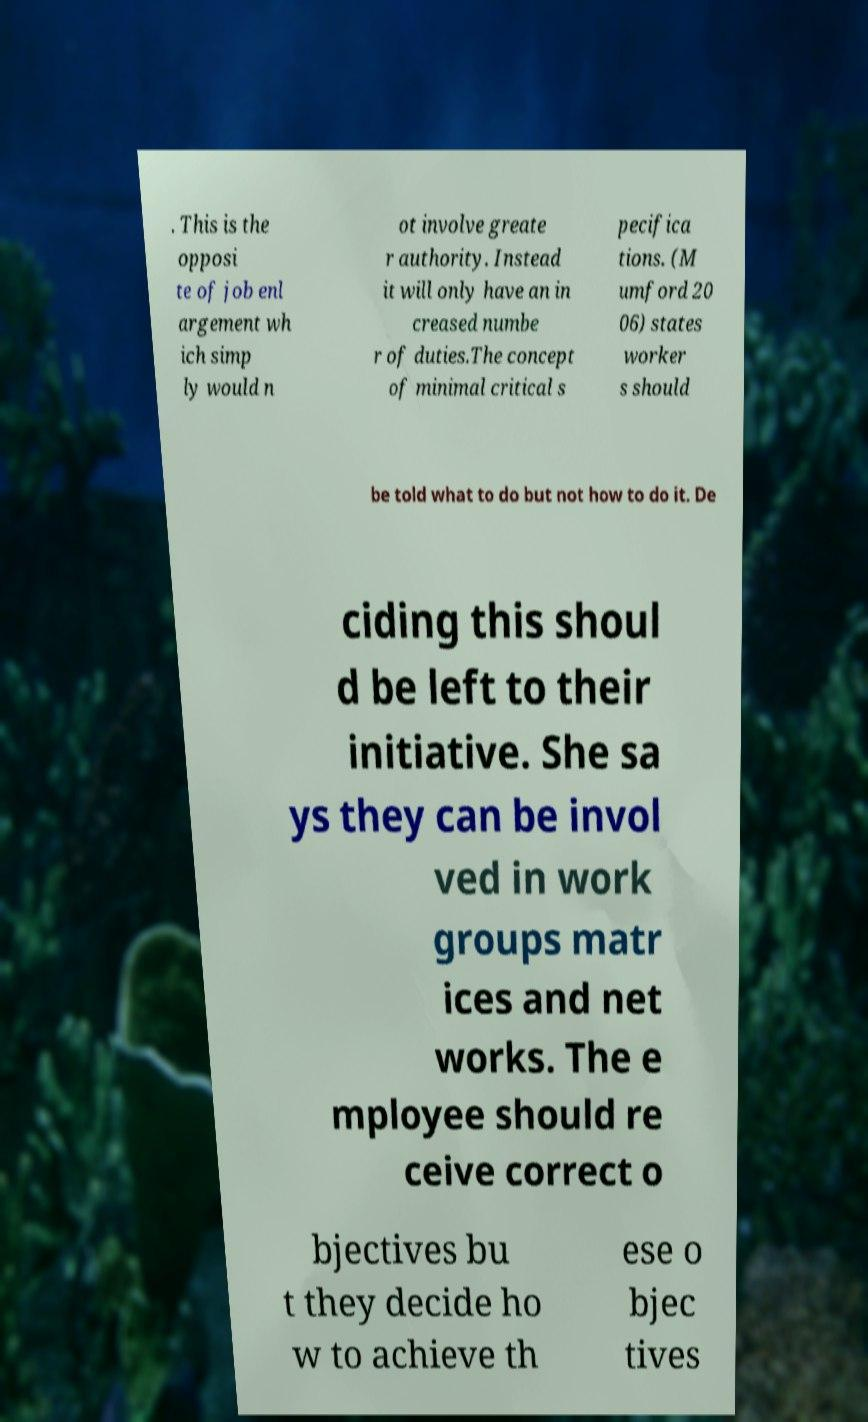I need the written content from this picture converted into text. Can you do that? . This is the opposi te of job enl argement wh ich simp ly would n ot involve greate r authority. Instead it will only have an in creased numbe r of duties.The concept of minimal critical s pecifica tions. (M umford 20 06) states worker s should be told what to do but not how to do it. De ciding this shoul d be left to their initiative. She sa ys they can be invol ved in work groups matr ices and net works. The e mployee should re ceive correct o bjectives bu t they decide ho w to achieve th ese o bjec tives 